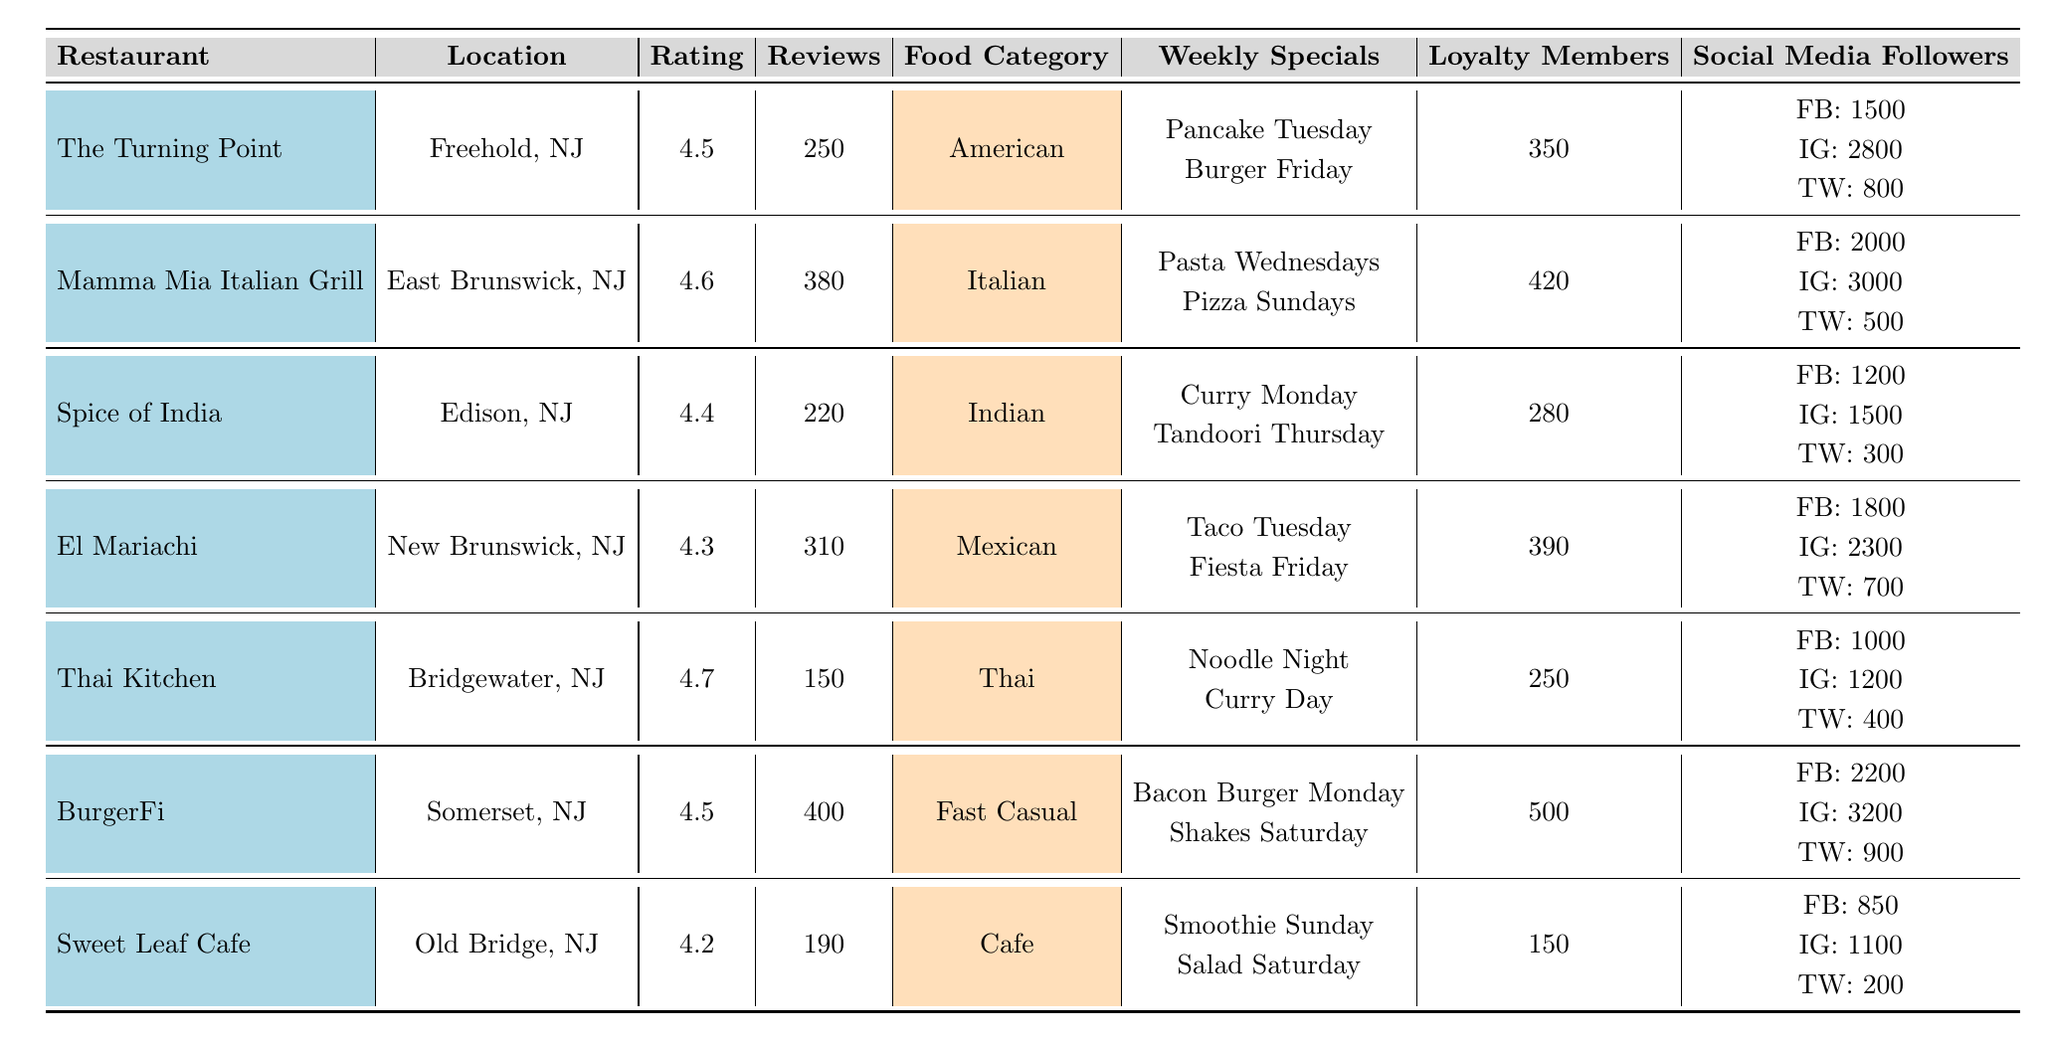What is the average rating of the restaurants listed? To find the average rating, sum the ratings of all restaurants: 4.5 + 4.6 + 4.4 + 4.3 + 4.7 + 4.5 + 4.2 = 31.2. There are 7 restaurants, so the average rating is 31.2 / 7 = 4.457.
Answer: 4.46 Which restaurant has the highest number of total reviews? The total reviews for each restaurant are: The Turning Point (250), Mamma Mia Italian Grill (380), Spice of India (220), El Mariachi (310), Thai Kitchen (150), BurgerFi (400), Sweet Leaf Cafe (190). The highest is BurgerFi with 400 reviews.
Answer: BurgerFi Is there a restaurant that has a loyalty program with more than 400 participants? The loyalty program participants are: The Turning Point (350), Mamma Mia Italian Grill (420), Spice of India (280), El Mariachi (390), Thai Kitchen (250), BurgerFi (500), Sweet Leaf Cafe (150). Mamma Mia Italian Grill and BurgerFi both exceed 400 participants.
Answer: Yes Which food category has the most restaurants listed? The food categories are: American (1), Italian (1), Indian (1), Mexican (1), Thai (1), Fast Casual (1), and Cafe (1). Each category has 1 restaurant, so they are all equal in number.
Answer: All have 1 What is the total number of social media followers across all platforms for BurgerFi? BurgerFi has 2200 Facebook followers, 3200 Instagram followers, and 900 Twitter followers. The total is 2200 + 3200 + 900 = 6300.
Answer: 6300 How many restaurants have an average rating above 4.5? The restaurants with ratings above 4.5 are: Mamma Mia Italian Grill (4.6), Thai Kitchen (4.7), and BurgerFi (4.5). Therefore, 3 restaurants meet this criterion (if we count 4.5 as above, then it’s 4).
Answer: 3 What is the difference in total reviews between the highest and lowest reviewed restaurants? The highest reviews are from BurgerFi (400) and the lowest from Thai Kitchen (150). The difference is 400 - 150 = 250.
Answer: 250 Which restaurant has the least number of social media followers? Analyzing the social media followers: The Turning Point (1500 FB + 2800 IG + 800 TW = 5100), Mamma Mia (2000 + 3000 + 500 = 5500), Spice of India (1200 + 1500 + 300 = 3000), El Mariachi (1800 + 2300 + 700 = 4800), Thai Kitchen (1000 + 1200 + 400 = 2600), BurgerFi (2200 + 3200 + 900 = 6300), Sweet Leaf Cafe (850 + 1100 + 200 = 2150). The least is Sweet Leaf Cafe with 2150.
Answer: Sweet Leaf Cafe What food category does the restaurant with the highest weekly specials belong to? The restaurant with the most weekly specials is BurgerFi, offering 2 specials: Bacon Burger Monday and Shakes Saturday. The food category for BurgerFi is Fast Casual.
Answer: Fast Casual Which restaurant has more loyalty program participants, El Mariachi or Spice of India? El Mariachi has 390 loyalty participants while Spice of India has 280. Since 390 is greater than 280, El Mariachi has more participants.
Answer: El Mariachi 